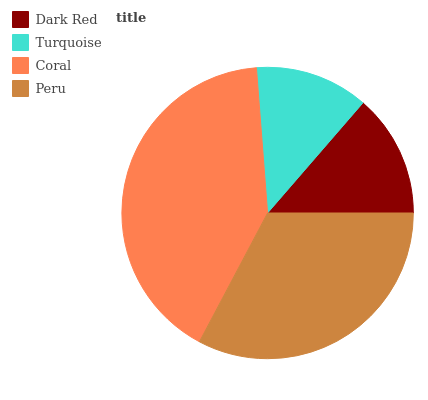Is Turquoise the minimum?
Answer yes or no. Yes. Is Coral the maximum?
Answer yes or no. Yes. Is Coral the minimum?
Answer yes or no. No. Is Turquoise the maximum?
Answer yes or no. No. Is Coral greater than Turquoise?
Answer yes or no. Yes. Is Turquoise less than Coral?
Answer yes or no. Yes. Is Turquoise greater than Coral?
Answer yes or no. No. Is Coral less than Turquoise?
Answer yes or no. No. Is Peru the high median?
Answer yes or no. Yes. Is Dark Red the low median?
Answer yes or no. Yes. Is Dark Red the high median?
Answer yes or no. No. Is Peru the low median?
Answer yes or no. No. 